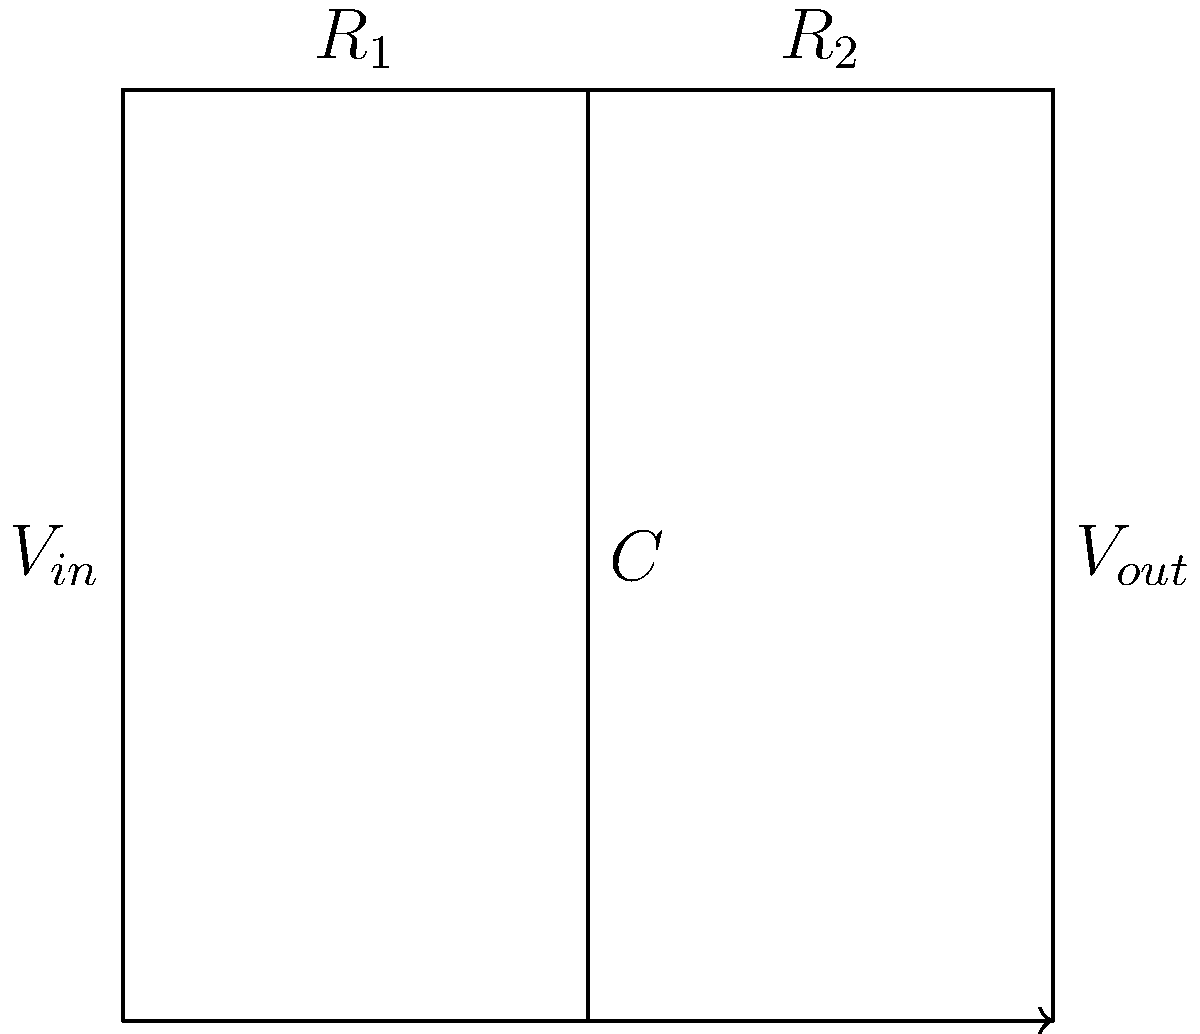In the given circuit diagram, which represents a voltage divider with a parallel capacitor, how would the output voltage $V_{out}$ change if we were to increase the frequency of the input signal $V_{in}$? Consider this in the context of the Ramayana's theme of change and adaptation. To understand this circuit's behavior, let's approach it step-by-step, drawing parallels to the Ramayana:

1) First, recognize that $R_1$ and $R_2$ form a voltage divider, similar to how Rama and Lakshmana divided their responsibilities in the forest.

2) The capacitor $C$ is in parallel with $R_2$, much like how Sita's presence complemented Rama's journey.

3) At low frequencies, the capacitor acts like an open circuit, and $V_{out}$ is determined by the voltage divider equation:

   $$V_{out} = V_{in} \cdot \frac{R_2}{R_1 + R_2}$$

4) As frequency increases, the capacitor's impedance decreases according to:

   $$X_C = \frac{1}{2\pi f C}$$

   This is analogous to how challenges in the Ramayana became more frequent and intense as the story progressed.

5) At higher frequencies, the capacitor begins to short out $R_2$, reducing the effective resistance of the bottom branch.

6) As a result, $V_{out}$ decreases with increasing frequency, much like how Rama's trials intensified throughout his journey.

7) At very high frequencies, the capacitor effectively acts as a short circuit, and $V_{out}$ approaches zero.

This behavior reflects the Ramayana's theme of adapting to changing circumstances, as the circuit's response changes with varying input frequencies.
Answer: $V_{out}$ decreases as frequency increases. 